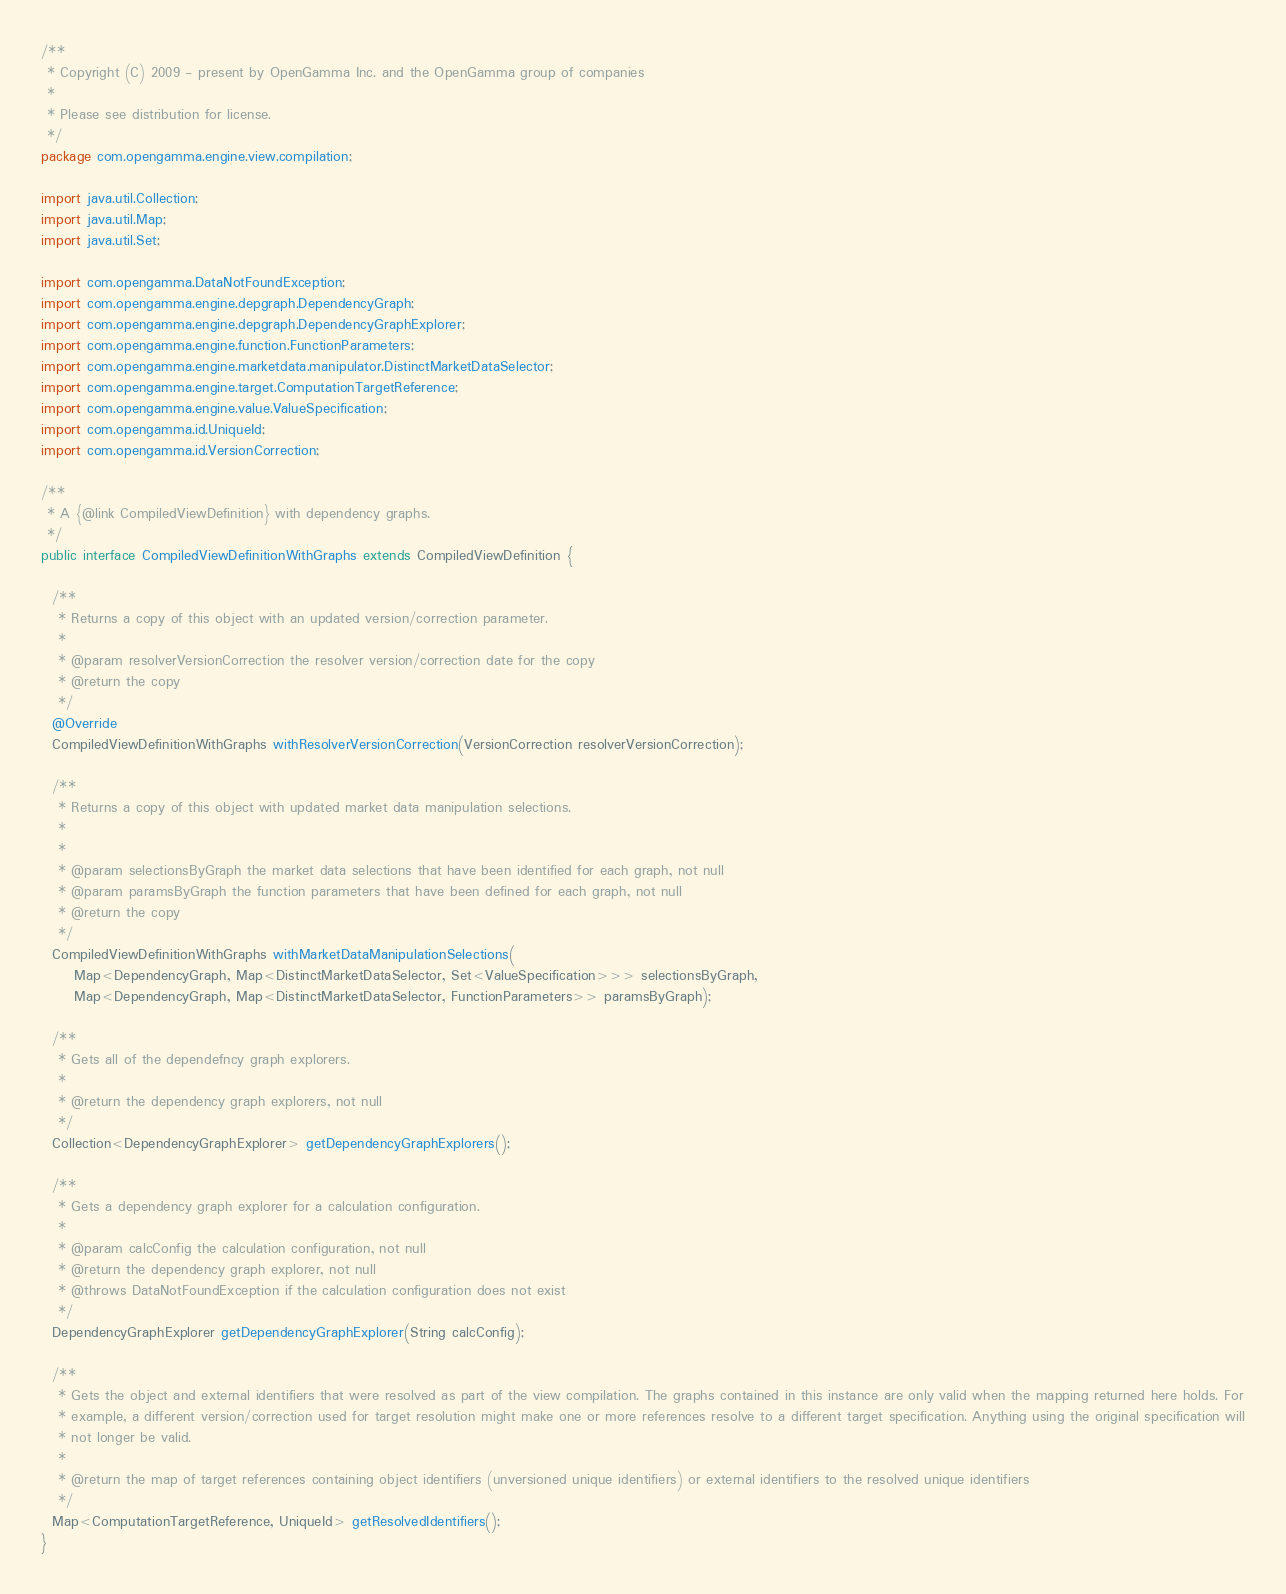Convert code to text. <code><loc_0><loc_0><loc_500><loc_500><_Java_>/**
 * Copyright (C) 2009 - present by OpenGamma Inc. and the OpenGamma group of companies
 *
 * Please see distribution for license.
 */
package com.opengamma.engine.view.compilation;

import java.util.Collection;
import java.util.Map;
import java.util.Set;

import com.opengamma.DataNotFoundException;
import com.opengamma.engine.depgraph.DependencyGraph;
import com.opengamma.engine.depgraph.DependencyGraphExplorer;
import com.opengamma.engine.function.FunctionParameters;
import com.opengamma.engine.marketdata.manipulator.DistinctMarketDataSelector;
import com.opengamma.engine.target.ComputationTargetReference;
import com.opengamma.engine.value.ValueSpecification;
import com.opengamma.id.UniqueId;
import com.opengamma.id.VersionCorrection;

/**
 * A {@link CompiledViewDefinition} with dependency graphs.
 */
public interface CompiledViewDefinitionWithGraphs extends CompiledViewDefinition {

  /**
   * Returns a copy of this object with an updated version/correction parameter.
   * 
   * @param resolverVersionCorrection the resolver version/correction date for the copy
   * @return the copy
   */
  @Override
  CompiledViewDefinitionWithGraphs withResolverVersionCorrection(VersionCorrection resolverVersionCorrection);

  /**
   * Returns a copy of this object with updated market data manipulation selections.
   *
   *
   * @param selectionsByGraph the market data selections that have been identified for each graph, not null
   * @param paramsByGraph the function parameters that have been defined for each graph, not null
   * @return the copy
   */
  CompiledViewDefinitionWithGraphs withMarketDataManipulationSelections(
      Map<DependencyGraph, Map<DistinctMarketDataSelector, Set<ValueSpecification>>> selectionsByGraph,
      Map<DependencyGraph, Map<DistinctMarketDataSelector, FunctionParameters>> paramsByGraph);

  /**
   * Gets all of the dependefncy graph explorers.
   * 
   * @return the dependency graph explorers, not null
   */
  Collection<DependencyGraphExplorer> getDependencyGraphExplorers();

  /**
   * Gets a dependency graph explorer for a calculation configuration.
   * 
   * @param calcConfig the calculation configuration, not null
   * @return the dependency graph explorer, not null
   * @throws DataNotFoundException if the calculation configuration does not exist
   */
  DependencyGraphExplorer getDependencyGraphExplorer(String calcConfig);

  /**
   * Gets the object and external identifiers that were resolved as part of the view compilation. The graphs contained in this instance are only valid when the mapping returned here holds. For
   * example, a different version/correction used for target resolution might make one or more references resolve to a different target specification. Anything using the original specification will
   * not longer be valid.
   * 
   * @return the map of target references containing object identifiers (unversioned unique identifiers) or external identifiers to the resolved unique identifiers
   */
  Map<ComputationTargetReference, UniqueId> getResolvedIdentifiers();
}
</code> 